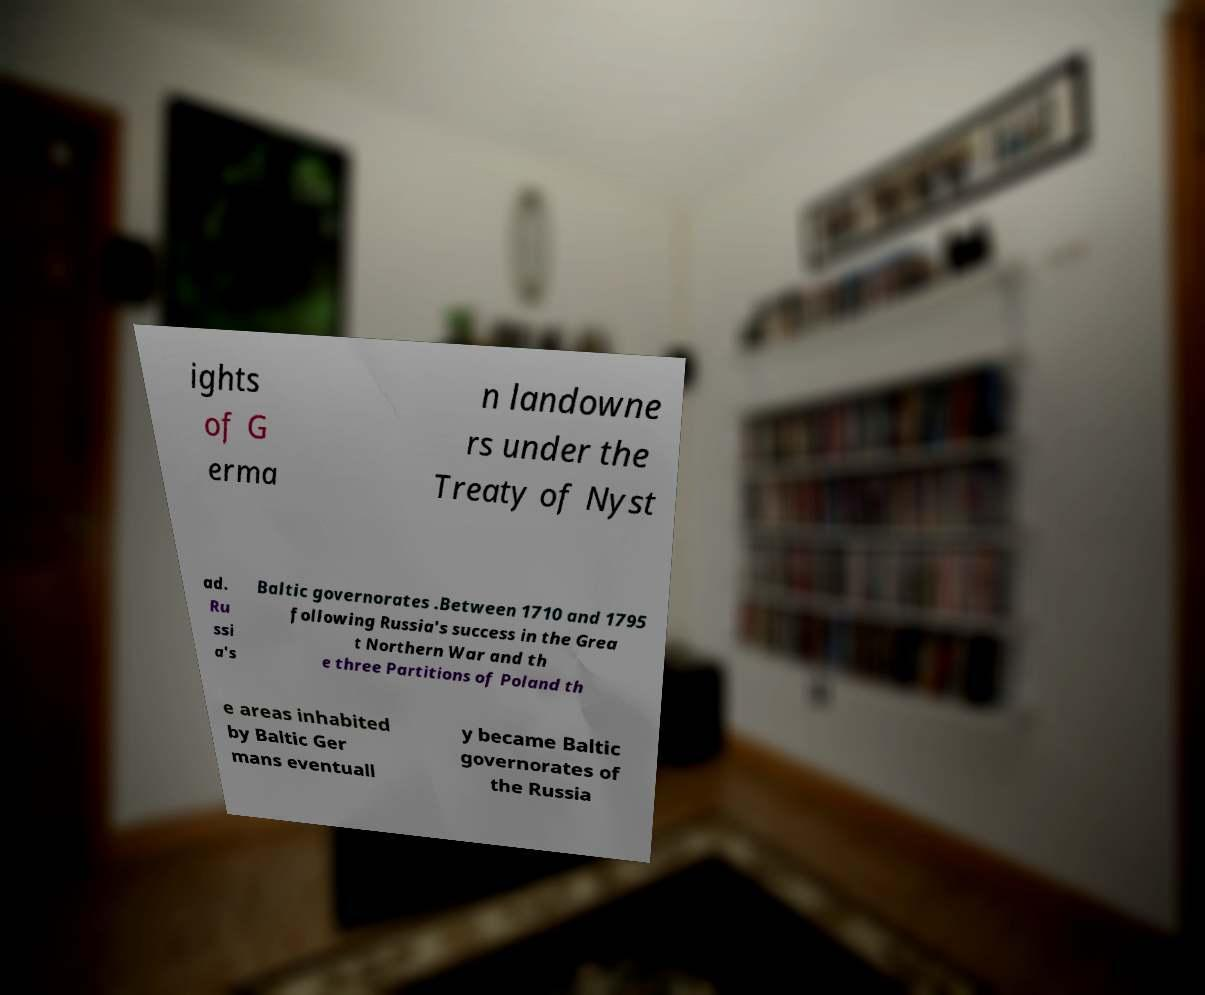Could you assist in decoding the text presented in this image and type it out clearly? ights of G erma n landowne rs under the Treaty of Nyst ad. Ru ssi a's Baltic governorates .Between 1710 and 1795 following Russia's success in the Grea t Northern War and th e three Partitions of Poland th e areas inhabited by Baltic Ger mans eventuall y became Baltic governorates of the Russia 